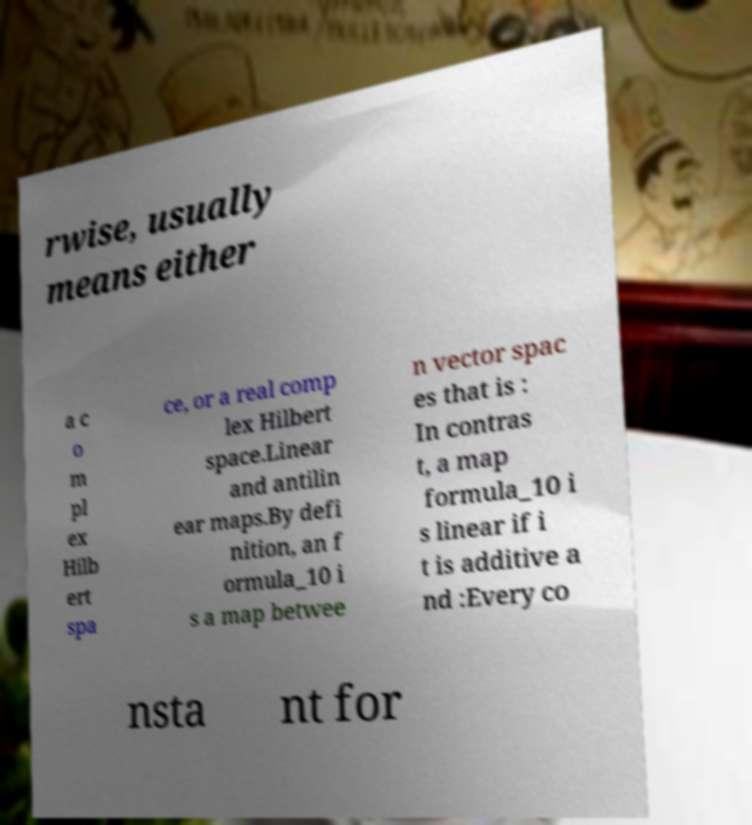Please identify and transcribe the text found in this image. rwise, usually means either a c o m pl ex Hilb ert spa ce, or a real comp lex Hilbert space.Linear and antilin ear maps.By defi nition, an f ormula_10 i s a map betwee n vector spac es that is : In contras t, a map formula_10 i s linear if i t is additive a nd :Every co nsta nt for 